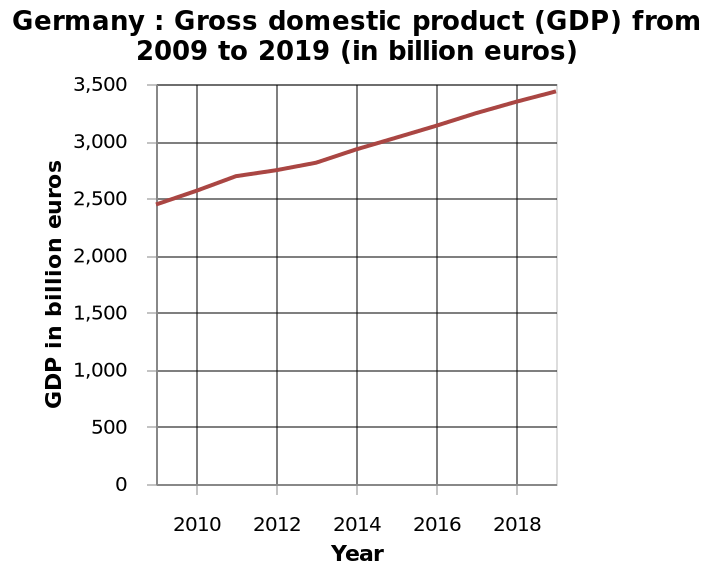<image>
What was the GDP in 2009? The GDP in 2009 was just below 2500 billion euros. In which year was the gross domestic product (GDP) the highest according to the line diagram? The line diagram does not provide specific values for each year, so it is not possible to determine the exact year when the GDP was the highest. Offer a thorough analysis of the image. A steady increase in GDP from 2.500 to 3, 500 from 2010 to 2018 as there are no peaks and troughs in the graph. 